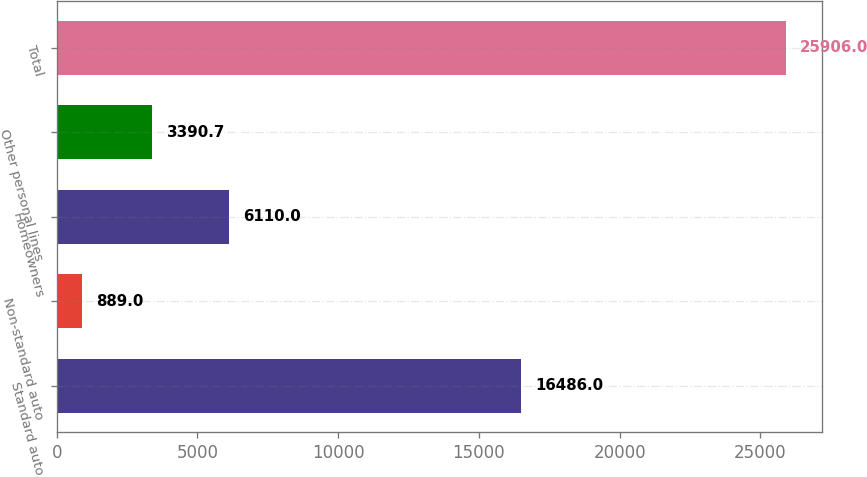<chart> <loc_0><loc_0><loc_500><loc_500><bar_chart><fcel>Standard auto<fcel>Non-standard auto<fcel>Homeowners<fcel>Other personal lines<fcel>Total<nl><fcel>16486<fcel>889<fcel>6110<fcel>3390.7<fcel>25906<nl></chart> 